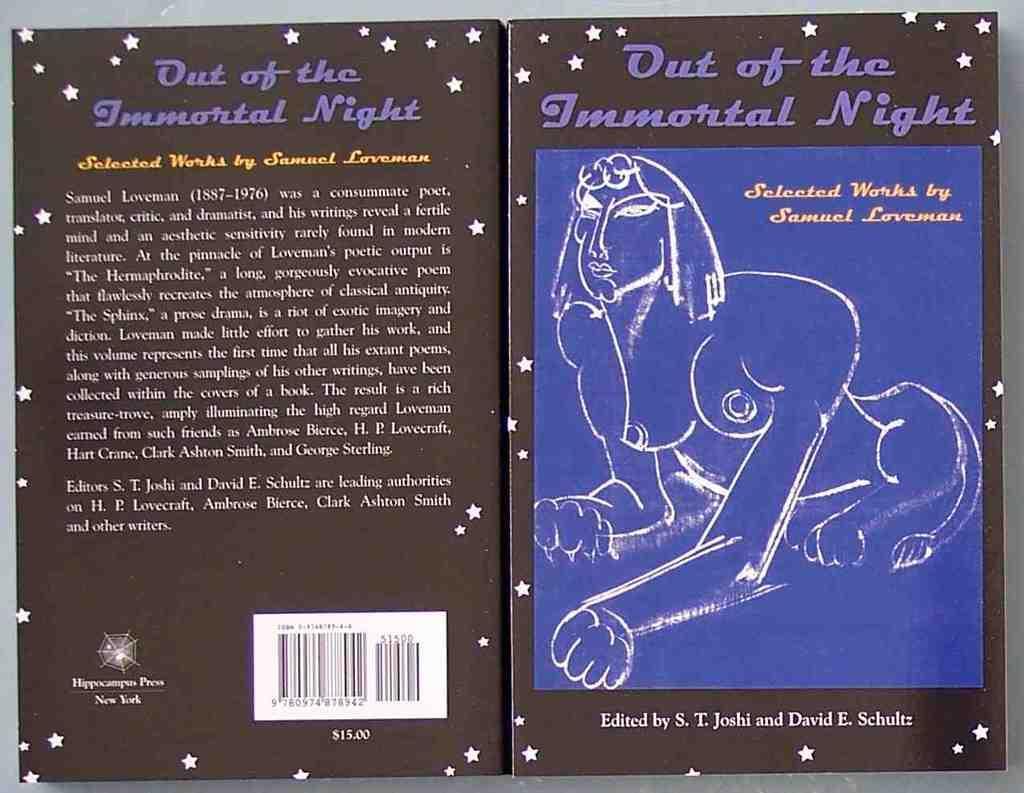Can you describe this image briefly? In this image we can see a box with text and image and with a barcode. 